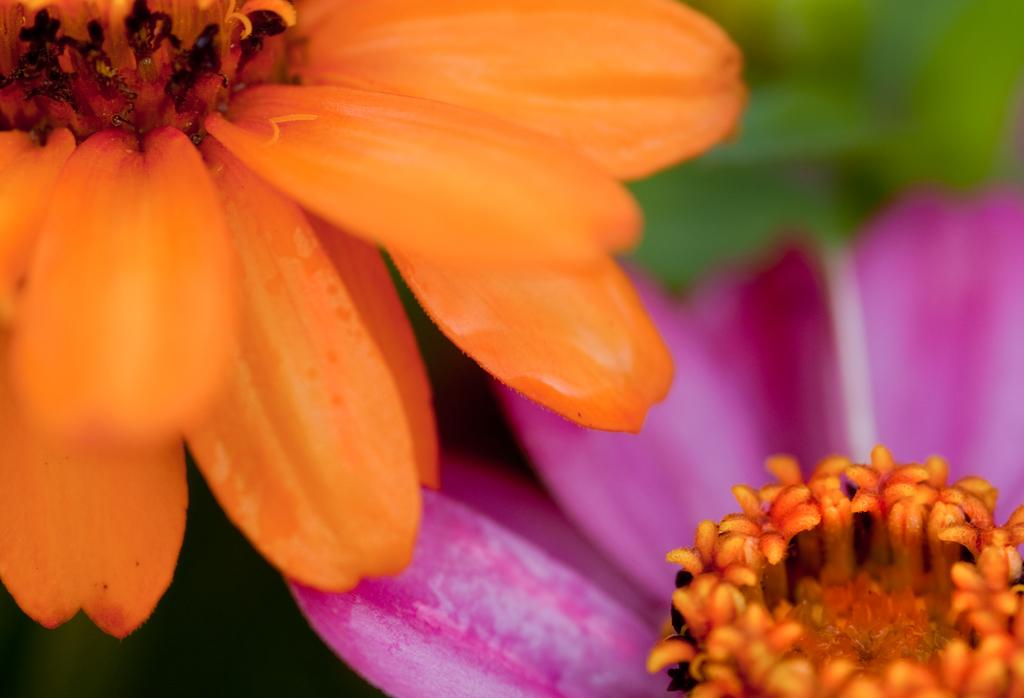How many flowers are in the image? There are two flowers in the image. What colors are the flowers? One flower is orange, and the other flower is pink. What rate do the flowers grow at in the image? The rate of growth for the flowers cannot be determined from the image, as it only shows the flowers in their current state. 